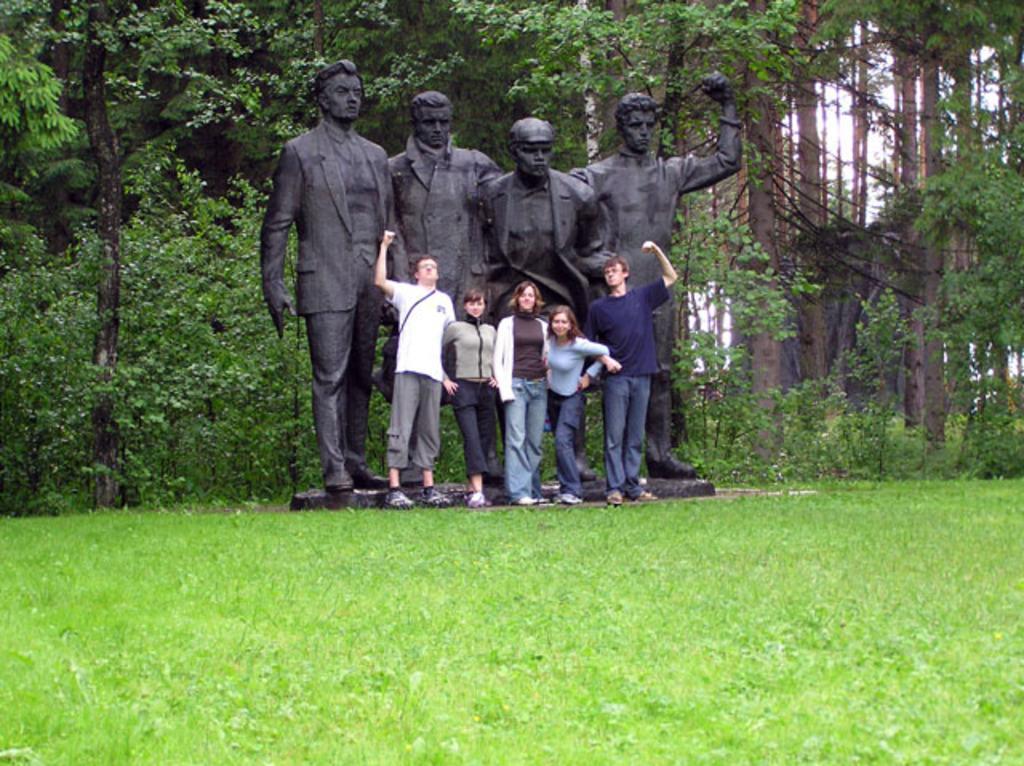In one or two sentences, can you explain what this image depicts? In this image in the front there's grass on the ground. In the center there are persons standing and there are statues. In the background there are trees. 